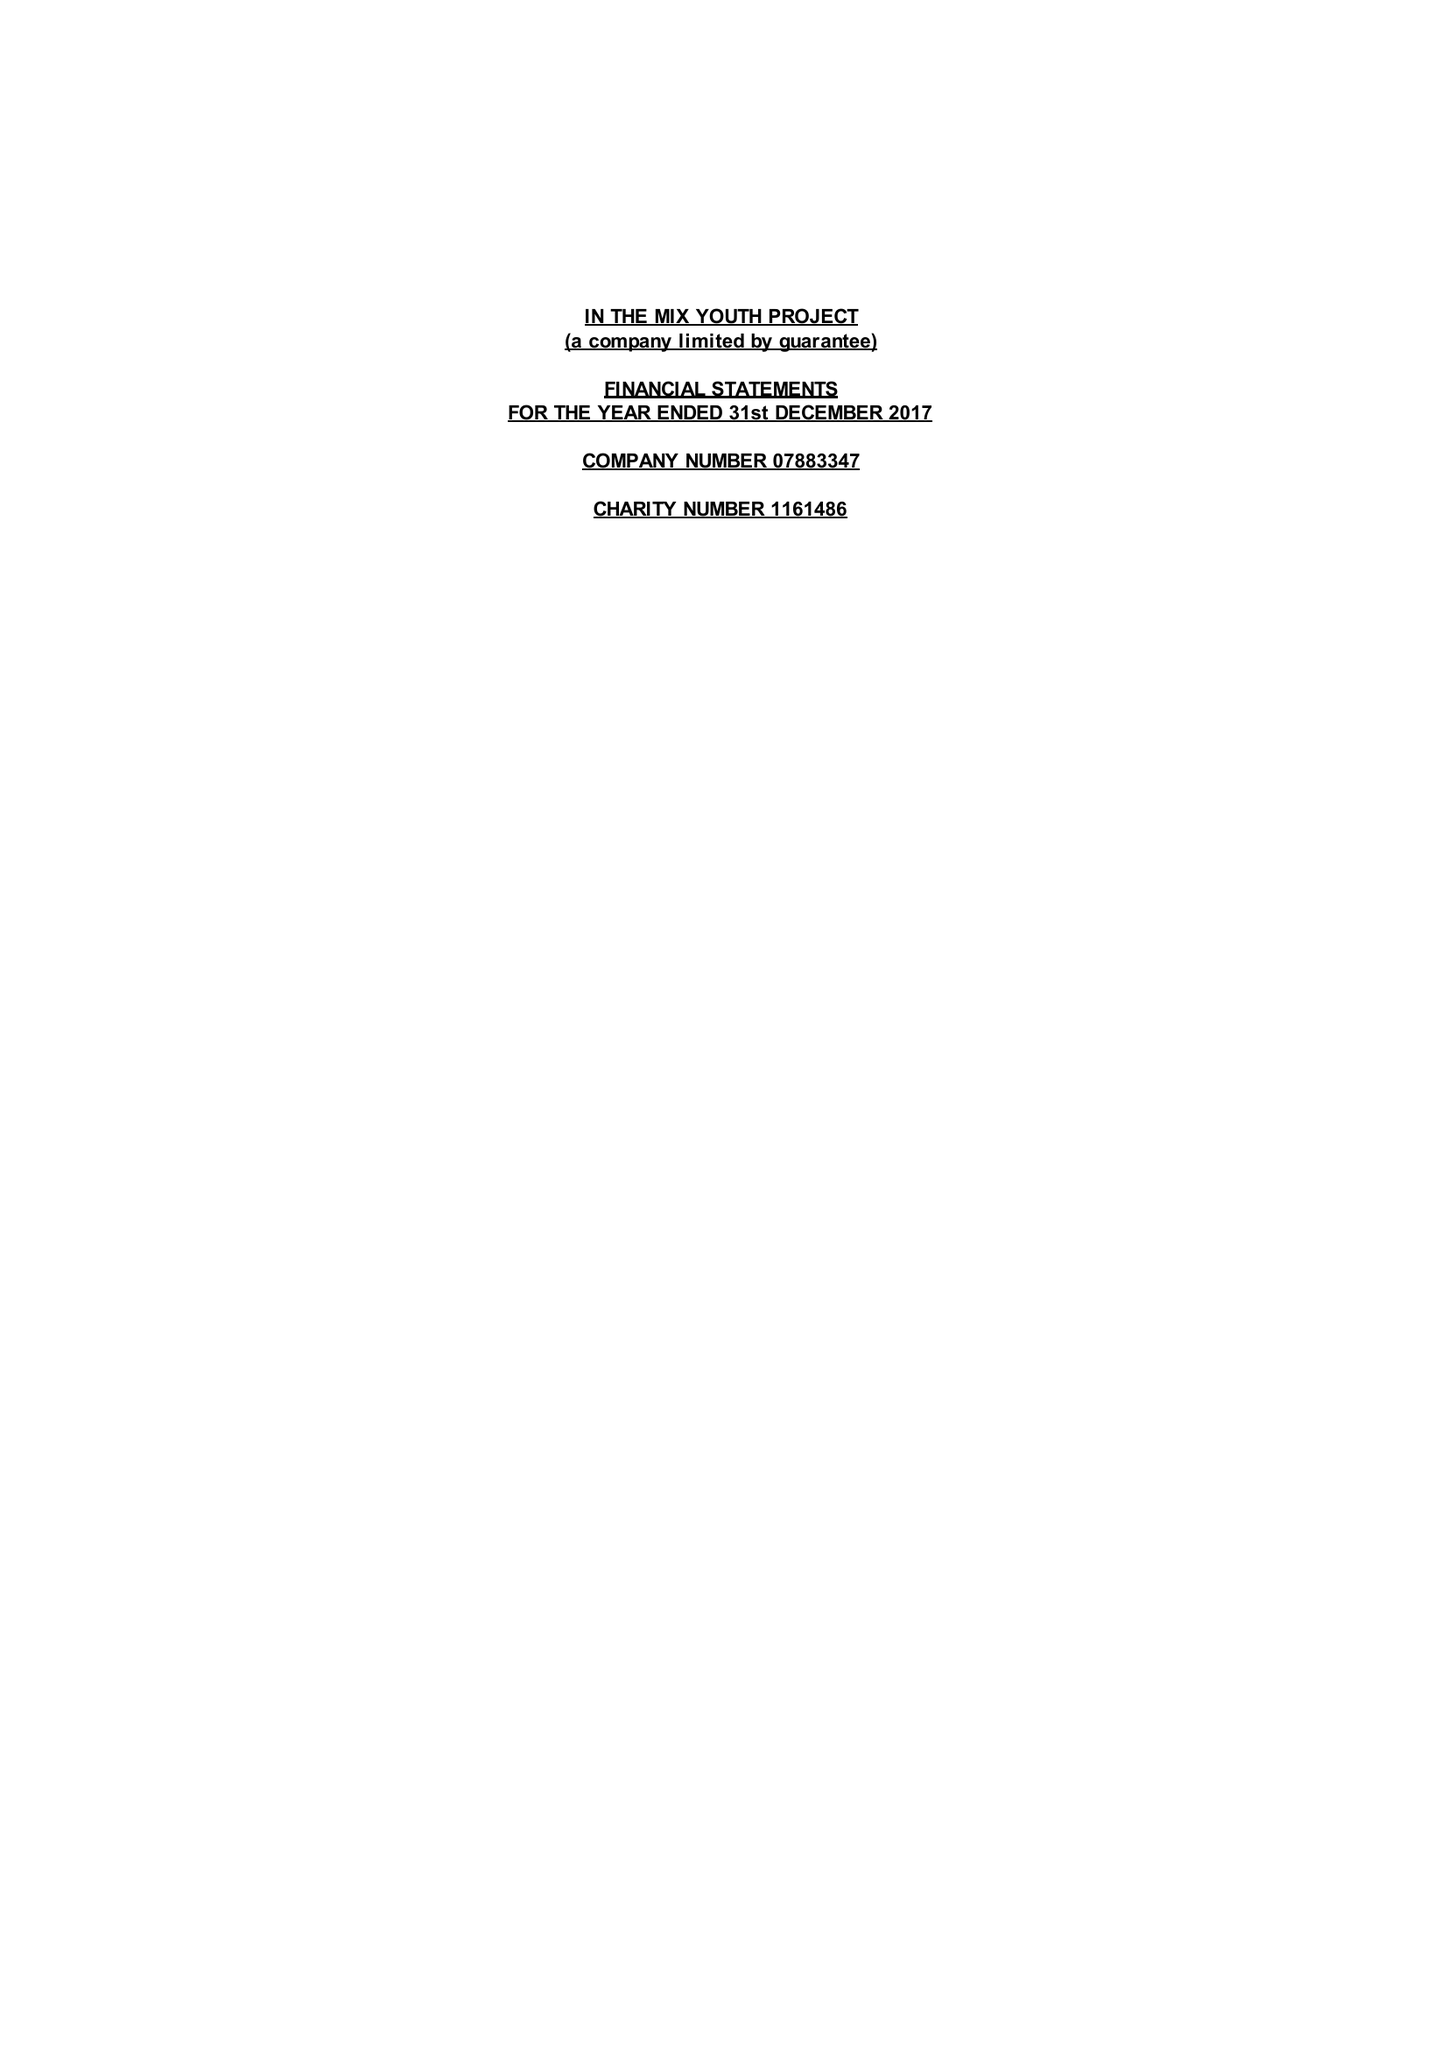What is the value for the address__street_line?
Answer the question using a single word or phrase. HARTSWELL 